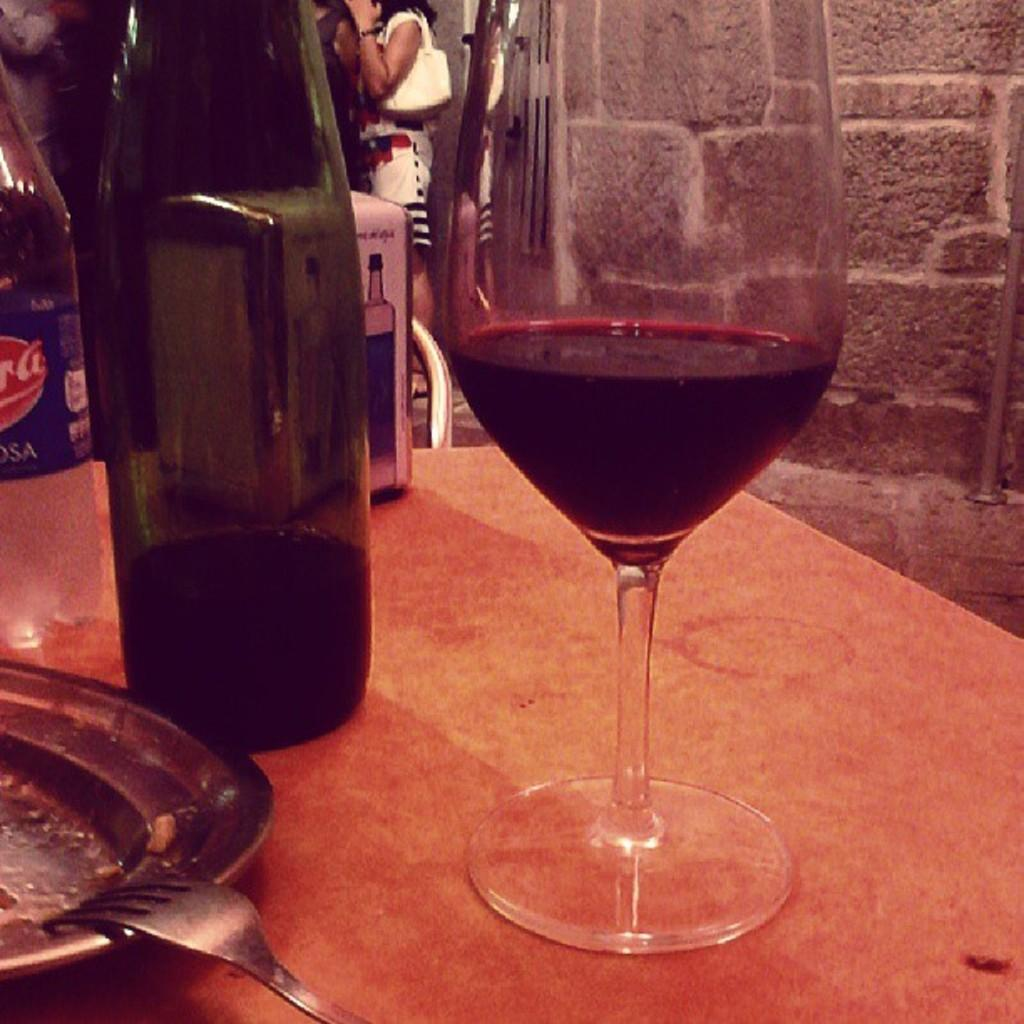What type of glass can be seen on the table in the image? There is a wine glass on the table in the image. What is placed next to the wine glass on the table? There is a wine bottle on the table. What is used for serving food on the table? There is a plate on the table. What utensil is placed on the plate? There is a fork on the plate. What type of goat can be seen grazing on the table in the image? There is no goat present in the image; it only features a wine glass, wine bottle, plate, and fork. What is the condition of the wine in the bottle? The condition of the wine in the bottle cannot be determined from the image alone, as it only shows the bottle and not the contents. 